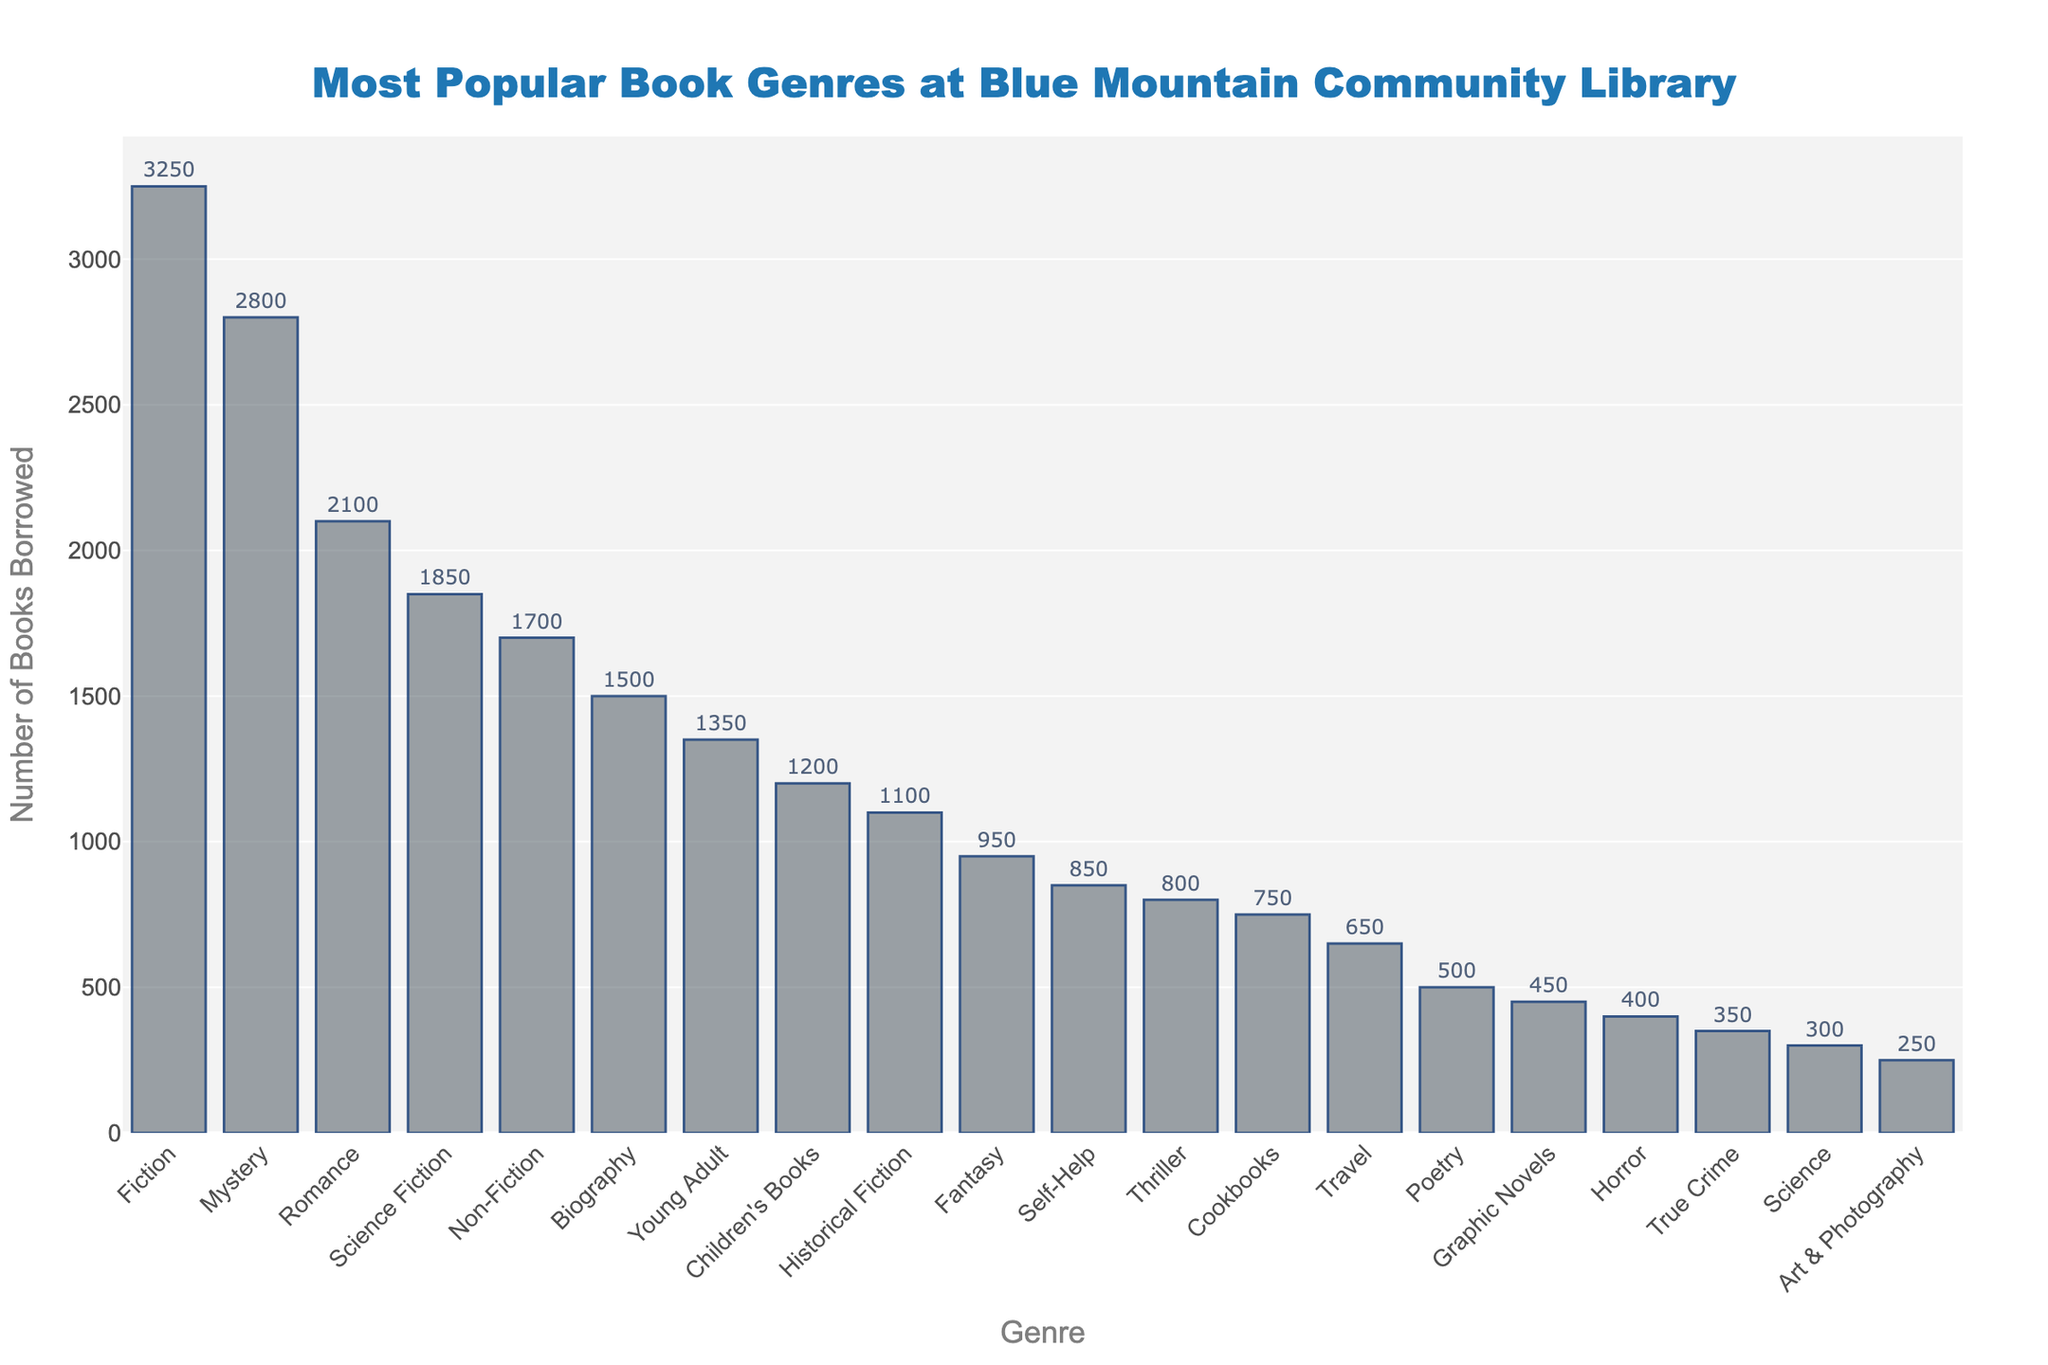Which genre has the highest number of books borrowed? The highest bar represents the genre with the most books borrowed. The highest bar corresponds to Fiction.
Answer: Fiction What is the difference in borrowing count between Fiction and Mystery? The bar for Fiction reaches 3250 and the bar for Mystery reaches 2800. Subtract the borrowing count of Mystery from Fiction: 3250 - 2800.
Answer: 450 Which genre has fewer books borrowed: Fantasy or Thriller? Compare the height of the bars for Fantasy and Thriller. The bar for Fantasy is slightly higher than Thriller. Fantasy has 950 and Thriller has 800.
Answer: Thriller How many more books were borrowed in Romance compared to Science Fiction? The bar for Romance reaches 2100 and the bar for Science Fiction reaches 1850. Subtract the borrowing count of Science Fiction from Romance: 2100 - 1850.
Answer: 250 What is the total number of books borrowed for Biography and Non-Fiction combined? Add the borrowing counts for Biography and Non-Fiction. Biography has 1500 and Non-Fiction has 1700. The total is 1500 + 1700.
Answer: 3200 What is the average number of books borrowed for the top five genres? The top five genres are Fiction (3250), Mystery (2800), Romance (2100), Science Fiction (1850), and Non-Fiction (1700). Sum these values: 3250 + 2800 + 2100 + 1850 + 1700 = 11700. Divide by 5.
Answer: 2340 Which genre has a borrowing count closest to 1000? Identify the bar closest to the 1000 mark. Historical Fiction is the closest with a borrowing count of 1100.
Answer: Historical Fiction Is the borrowing count for Self-Help higher or lower than for Children's Books? Compare the heights of the bars for Self-Help and Children's Books. The bar for Self-Help is lower than that for Children's Books. Self-Help has 850 and Children's Books has 1200.
Answer: Lower What is the sum of borrowing counts for genres ranked in the 10th and 15th place? Fantasy (10th place) has 950 and Poetry (15th place) has 500. Sum these values: 950 + 500.
Answer: 1450 How many genres have a borrowing count less than 500? Identify bars shorter than the 500 mark. Poetry (500), Graphic Novels (450), Horror (400), True Crime (350), Science (300), and Art & Photography (250) meet this criterion.
Answer: 6 